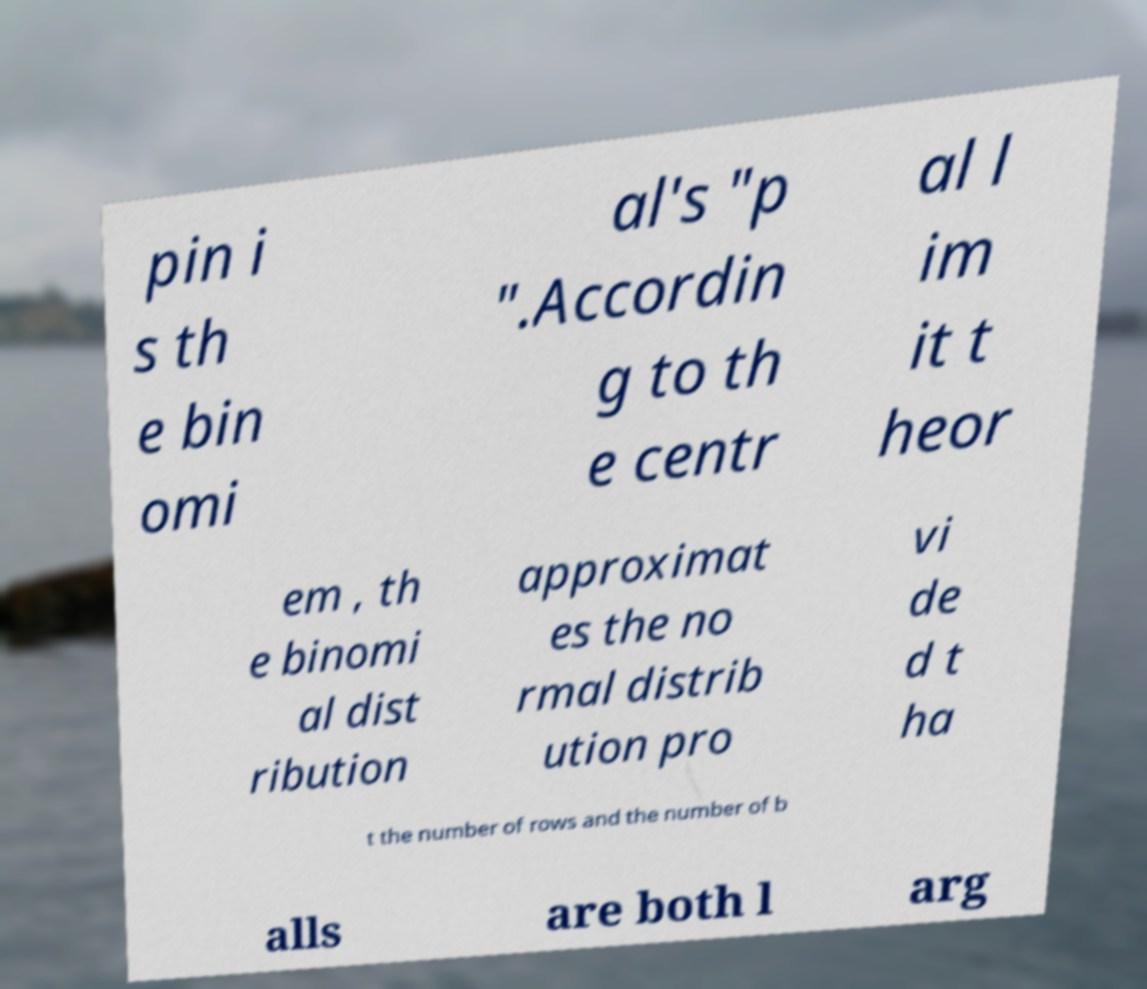For documentation purposes, I need the text within this image transcribed. Could you provide that? pin i s th e bin omi al's "p ".Accordin g to th e centr al l im it t heor em , th e binomi al dist ribution approximat es the no rmal distrib ution pro vi de d t ha t the number of rows and the number of b alls are both l arg 